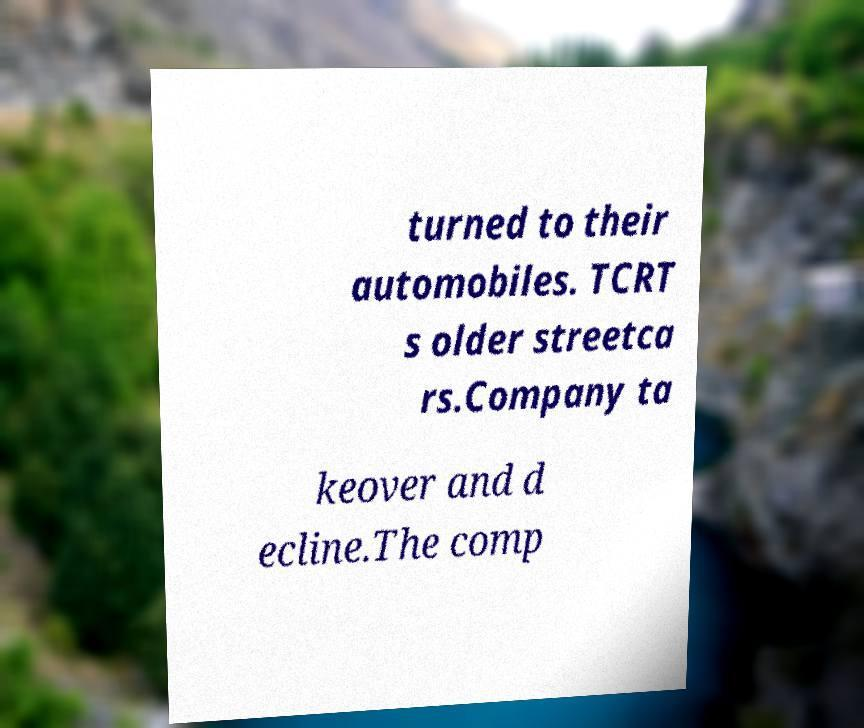There's text embedded in this image that I need extracted. Can you transcribe it verbatim? turned to their automobiles. TCRT s older streetca rs.Company ta keover and d ecline.The comp 